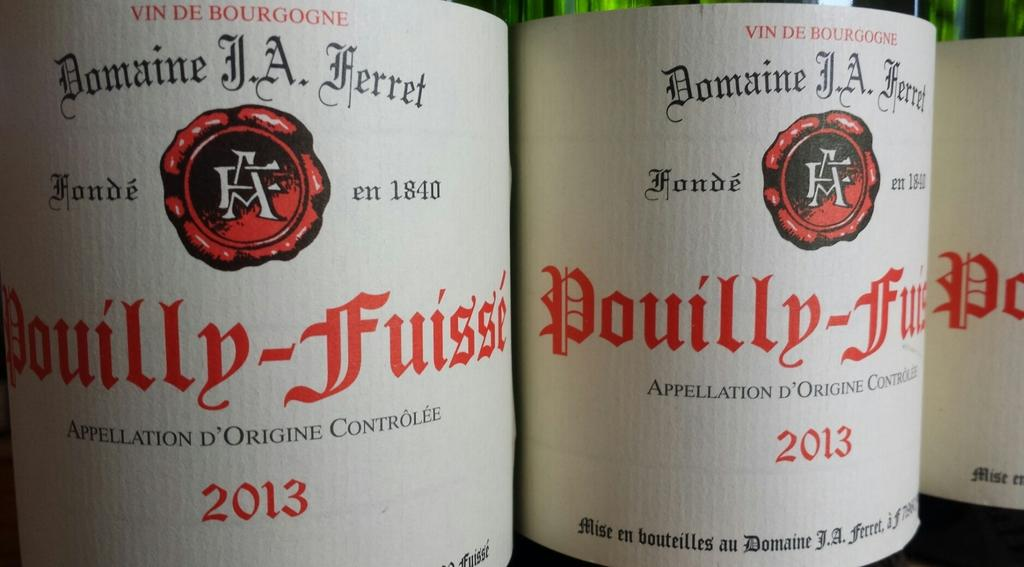What type of objects can be seen in the image? There are stickers, text, and logos in the image. What is the color of the top part of the image? The top of the image has a green color. Can you see a frog jumping in the image? There is no frog present in the image. What type of frame surrounds the image? The provided facts do not mention a frame surrounding the image. 